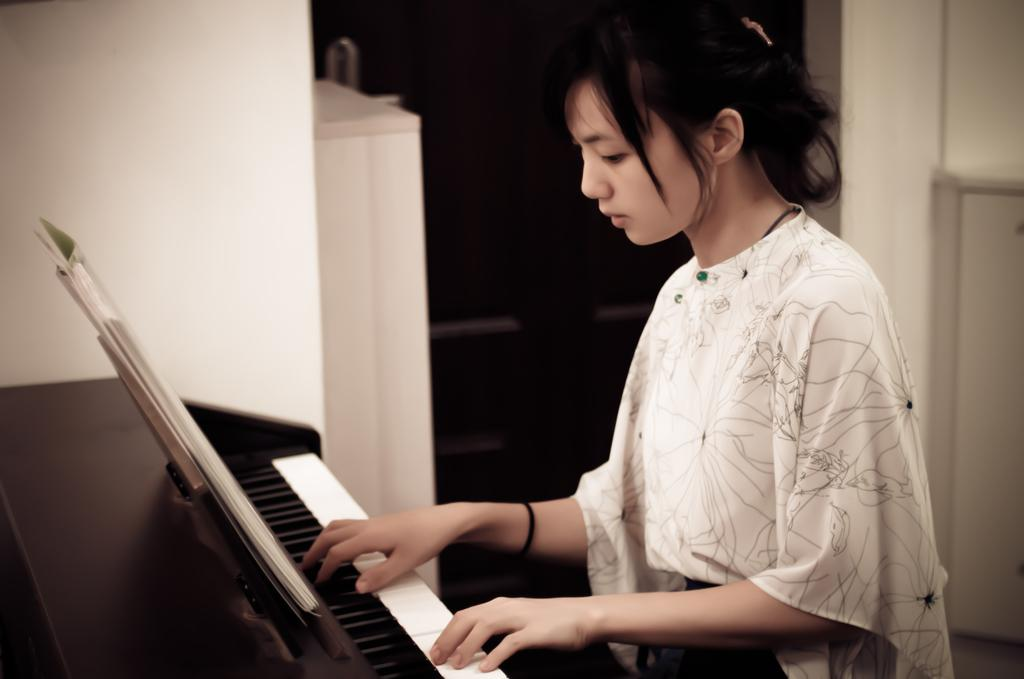What is the woman in the image doing? The woman is playing a piano. What object is in front of the woman? There is a book in front of the woman. What can be seen on the wall behind the woman? There is a white color wall in the background. What other furniture is visible in the background? There is a cupboard in the background. What part of the room is visible in the image? The floor is visible in the image. What type of current is flowing through the dolls in the image? There are no dolls present in the image, so there is no current flowing through any dolls. 